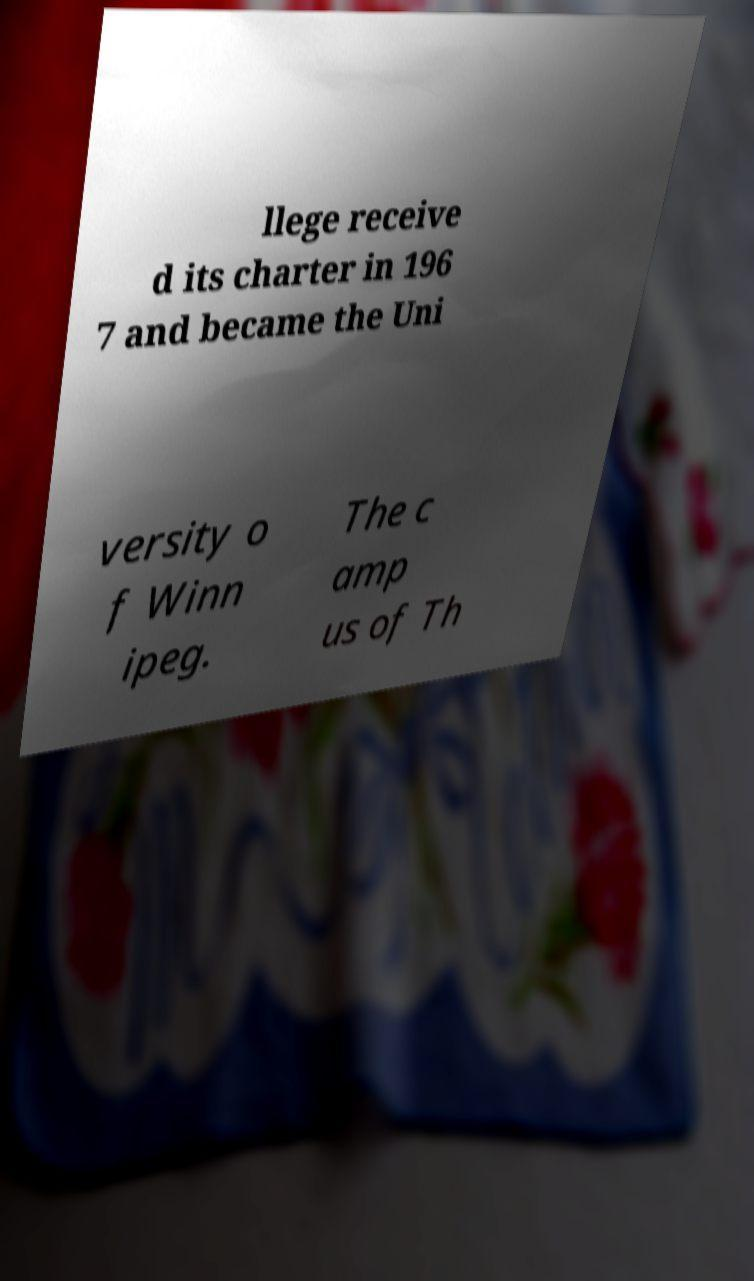Can you read and provide the text displayed in the image?This photo seems to have some interesting text. Can you extract and type it out for me? llege receive d its charter in 196 7 and became the Uni versity o f Winn ipeg. The c amp us of Th 